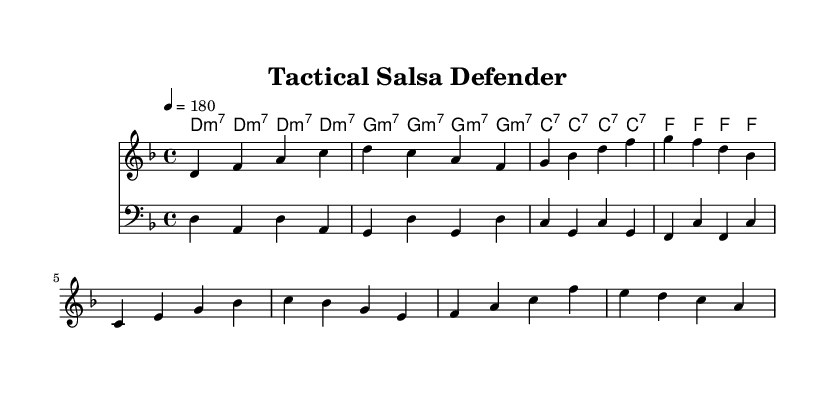What is the key signature of this music? The key signature is D minor, indicated by one flat (B flat) in the key signature area.
Answer: D minor What is the time signature of this music? The time signature is 4/4, which is shown at the beginning of the score following the key signature.
Answer: 4/4 What is the tempo marking provided? The tempo marking is indicated as quarter note equals 180 beats per minute, which is specified at the top of the score.
Answer: 180 How many measures are there in the melody? The melody consists of 8 measures, as there are 8 sequences of four beats each line in the provided melody.
Answer: 8 What is the function of the "chordNames" in the score? The "chordNames" provides the harmonic structure or chords that accompany the melody, aligned with the respective measures.
Answer: Provides harmonic structure What is the focus of the first verse's lyrics? The focus of the first verse emphasizes unity, understanding patterns, and strategic awareness in a game scenario, aligning with the tactical theme of the lyrics.
Answer: Unity and strategy What type of music is this piece classified as? This piece is classified as Latin music, specifically Salsa, given the rhythmic patterns and thematic content that highlight dancing and teamwork.
Answer: Salsa 